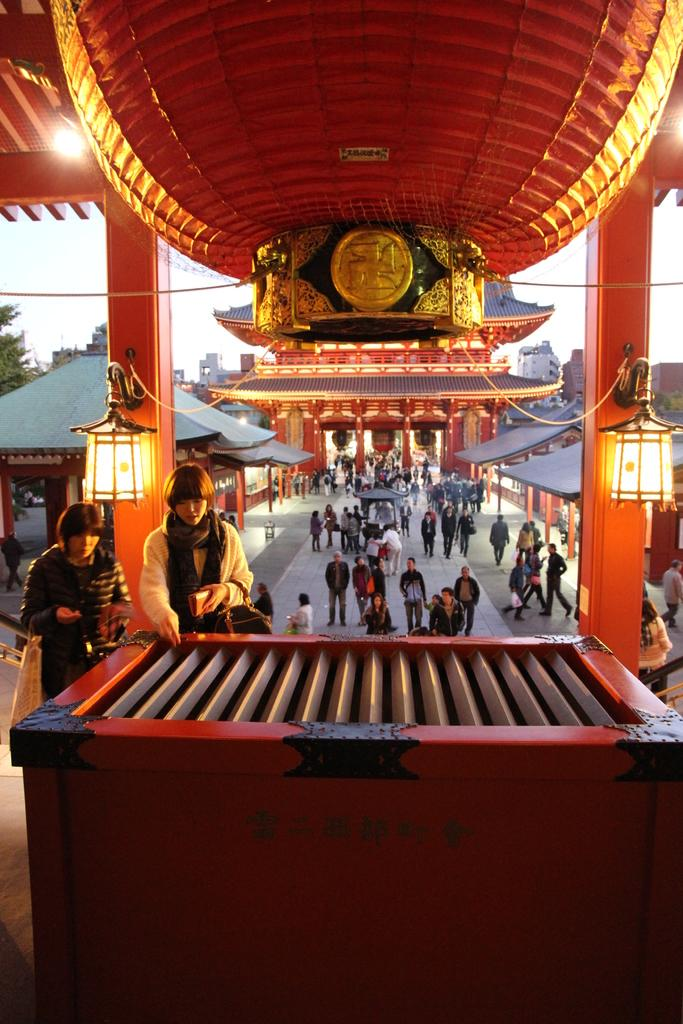How many people are in the image? There are two people in the image. What is the location of the people in the image? The people are in front of a table-like object. What is above the table-like object? There is a lamp above the table-like object. What type of structures can be seen in the image? There are sheds in the image. Can you describe the people in the image? There are people visible in the image. What other unspecified objects can be seen in the image? There are other unspecified objects in the image. What type of popcorn is being smashed by the people in the image? There is no popcorn or smashing activity present in the image. How does the breath of the people in the image affect the objects around them? There is no mention of the people's breath affecting any objects in the image. 